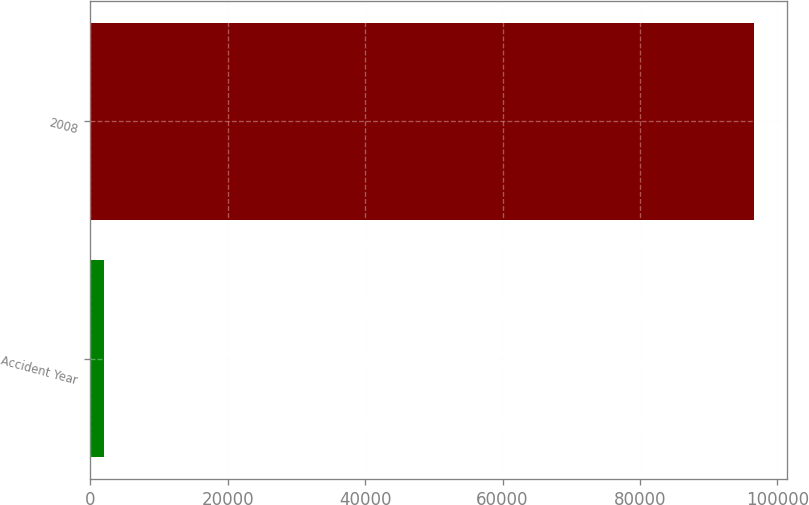Convert chart to OTSL. <chart><loc_0><loc_0><loc_500><loc_500><bar_chart><fcel>Accident Year<fcel>2008<nl><fcel>2012<fcel>96621<nl></chart> 